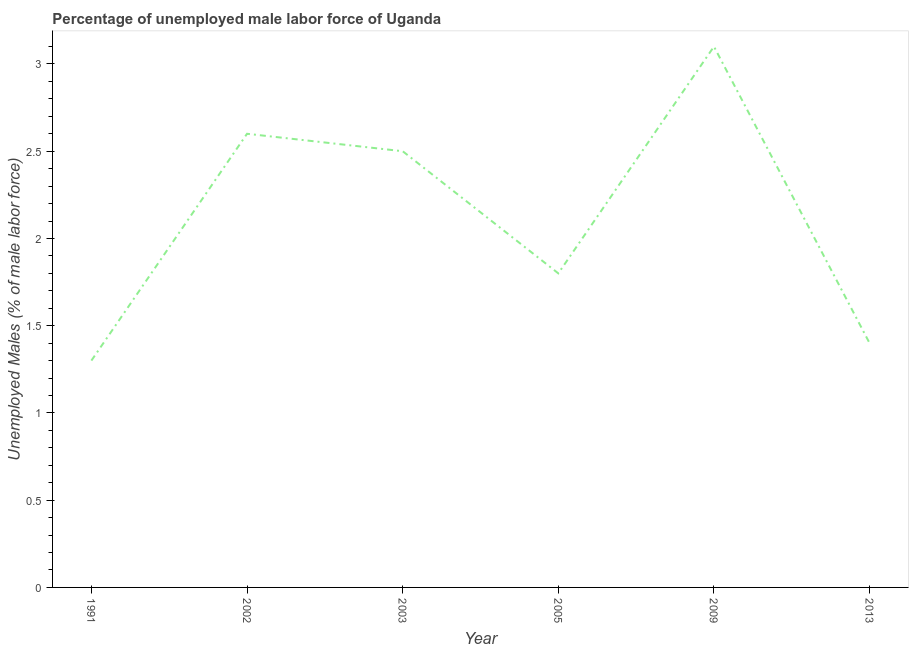What is the total unemployed male labour force in 2013?
Ensure brevity in your answer.  1.4. Across all years, what is the maximum total unemployed male labour force?
Ensure brevity in your answer.  3.1. Across all years, what is the minimum total unemployed male labour force?
Offer a terse response. 1.3. In which year was the total unemployed male labour force maximum?
Offer a terse response. 2009. In which year was the total unemployed male labour force minimum?
Provide a short and direct response. 1991. What is the sum of the total unemployed male labour force?
Ensure brevity in your answer.  12.7. What is the difference between the total unemployed male labour force in 1991 and 2003?
Offer a terse response. -1.2. What is the average total unemployed male labour force per year?
Your answer should be very brief. 2.12. What is the median total unemployed male labour force?
Your answer should be very brief. 2.15. Do a majority of the years between 2003 and 2005 (inclusive) have total unemployed male labour force greater than 1.6 %?
Keep it short and to the point. Yes. What is the ratio of the total unemployed male labour force in 2005 to that in 2013?
Offer a terse response. 1.29. What is the difference between the highest and the second highest total unemployed male labour force?
Offer a very short reply. 0.5. Is the sum of the total unemployed male labour force in 2003 and 2013 greater than the maximum total unemployed male labour force across all years?
Offer a very short reply. Yes. What is the difference between the highest and the lowest total unemployed male labour force?
Give a very brief answer. 1.8. Are the values on the major ticks of Y-axis written in scientific E-notation?
Keep it short and to the point. No. What is the title of the graph?
Keep it short and to the point. Percentage of unemployed male labor force of Uganda. What is the label or title of the Y-axis?
Provide a succinct answer. Unemployed Males (% of male labor force). What is the Unemployed Males (% of male labor force) of 1991?
Offer a very short reply. 1.3. What is the Unemployed Males (% of male labor force) in 2002?
Offer a very short reply. 2.6. What is the Unemployed Males (% of male labor force) of 2005?
Ensure brevity in your answer.  1.8. What is the Unemployed Males (% of male labor force) in 2009?
Ensure brevity in your answer.  3.1. What is the Unemployed Males (% of male labor force) of 2013?
Keep it short and to the point. 1.4. What is the difference between the Unemployed Males (% of male labor force) in 1991 and 2002?
Make the answer very short. -1.3. What is the difference between the Unemployed Males (% of male labor force) in 1991 and 2013?
Make the answer very short. -0.1. What is the difference between the Unemployed Males (% of male labor force) in 2005 and 2013?
Your answer should be very brief. 0.4. What is the difference between the Unemployed Males (% of male labor force) in 2009 and 2013?
Provide a short and direct response. 1.7. What is the ratio of the Unemployed Males (% of male labor force) in 1991 to that in 2002?
Your response must be concise. 0.5. What is the ratio of the Unemployed Males (% of male labor force) in 1991 to that in 2003?
Ensure brevity in your answer.  0.52. What is the ratio of the Unemployed Males (% of male labor force) in 1991 to that in 2005?
Make the answer very short. 0.72. What is the ratio of the Unemployed Males (% of male labor force) in 1991 to that in 2009?
Ensure brevity in your answer.  0.42. What is the ratio of the Unemployed Males (% of male labor force) in 1991 to that in 2013?
Give a very brief answer. 0.93. What is the ratio of the Unemployed Males (% of male labor force) in 2002 to that in 2003?
Keep it short and to the point. 1.04. What is the ratio of the Unemployed Males (% of male labor force) in 2002 to that in 2005?
Keep it short and to the point. 1.44. What is the ratio of the Unemployed Males (% of male labor force) in 2002 to that in 2009?
Give a very brief answer. 0.84. What is the ratio of the Unemployed Males (% of male labor force) in 2002 to that in 2013?
Your answer should be compact. 1.86. What is the ratio of the Unemployed Males (% of male labor force) in 2003 to that in 2005?
Provide a succinct answer. 1.39. What is the ratio of the Unemployed Males (% of male labor force) in 2003 to that in 2009?
Ensure brevity in your answer.  0.81. What is the ratio of the Unemployed Males (% of male labor force) in 2003 to that in 2013?
Keep it short and to the point. 1.79. What is the ratio of the Unemployed Males (% of male labor force) in 2005 to that in 2009?
Make the answer very short. 0.58. What is the ratio of the Unemployed Males (% of male labor force) in 2005 to that in 2013?
Offer a very short reply. 1.29. What is the ratio of the Unemployed Males (% of male labor force) in 2009 to that in 2013?
Your response must be concise. 2.21. 